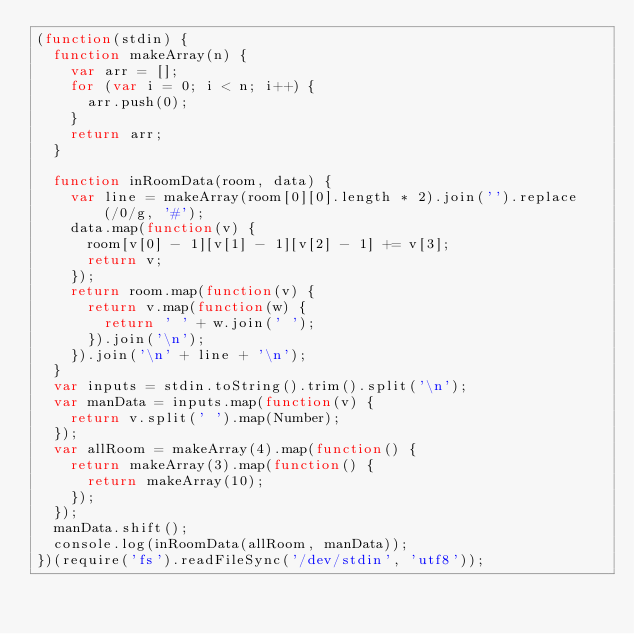Convert code to text. <code><loc_0><loc_0><loc_500><loc_500><_JavaScript_>(function(stdin) {
  function makeArray(n) {
    var arr = [];
    for (var i = 0; i < n; i++) {
      arr.push(0);
    }
    return arr;
  }

  function inRoomData(room, data) {
    var line = makeArray(room[0][0].length * 2).join('').replace(/0/g, '#');
    data.map(function(v) {
      room[v[0] - 1][v[1] - 1][v[2] - 1] += v[3];
      return v;
    });
    return room.map(function(v) {
      return v.map(function(w) {
        return ' ' + w.join(' ');
      }).join('\n');
    }).join('\n' + line + '\n');
  }
  var inputs = stdin.toString().trim().split('\n');
  var manData = inputs.map(function(v) {
    return v.split(' ').map(Number);
  });
  var allRoom = makeArray(4).map(function() {
    return makeArray(3).map(function() {
      return makeArray(10);
    });
  });
  manData.shift();
  console.log(inRoomData(allRoom, manData));
})(require('fs').readFileSync('/dev/stdin', 'utf8'));</code> 